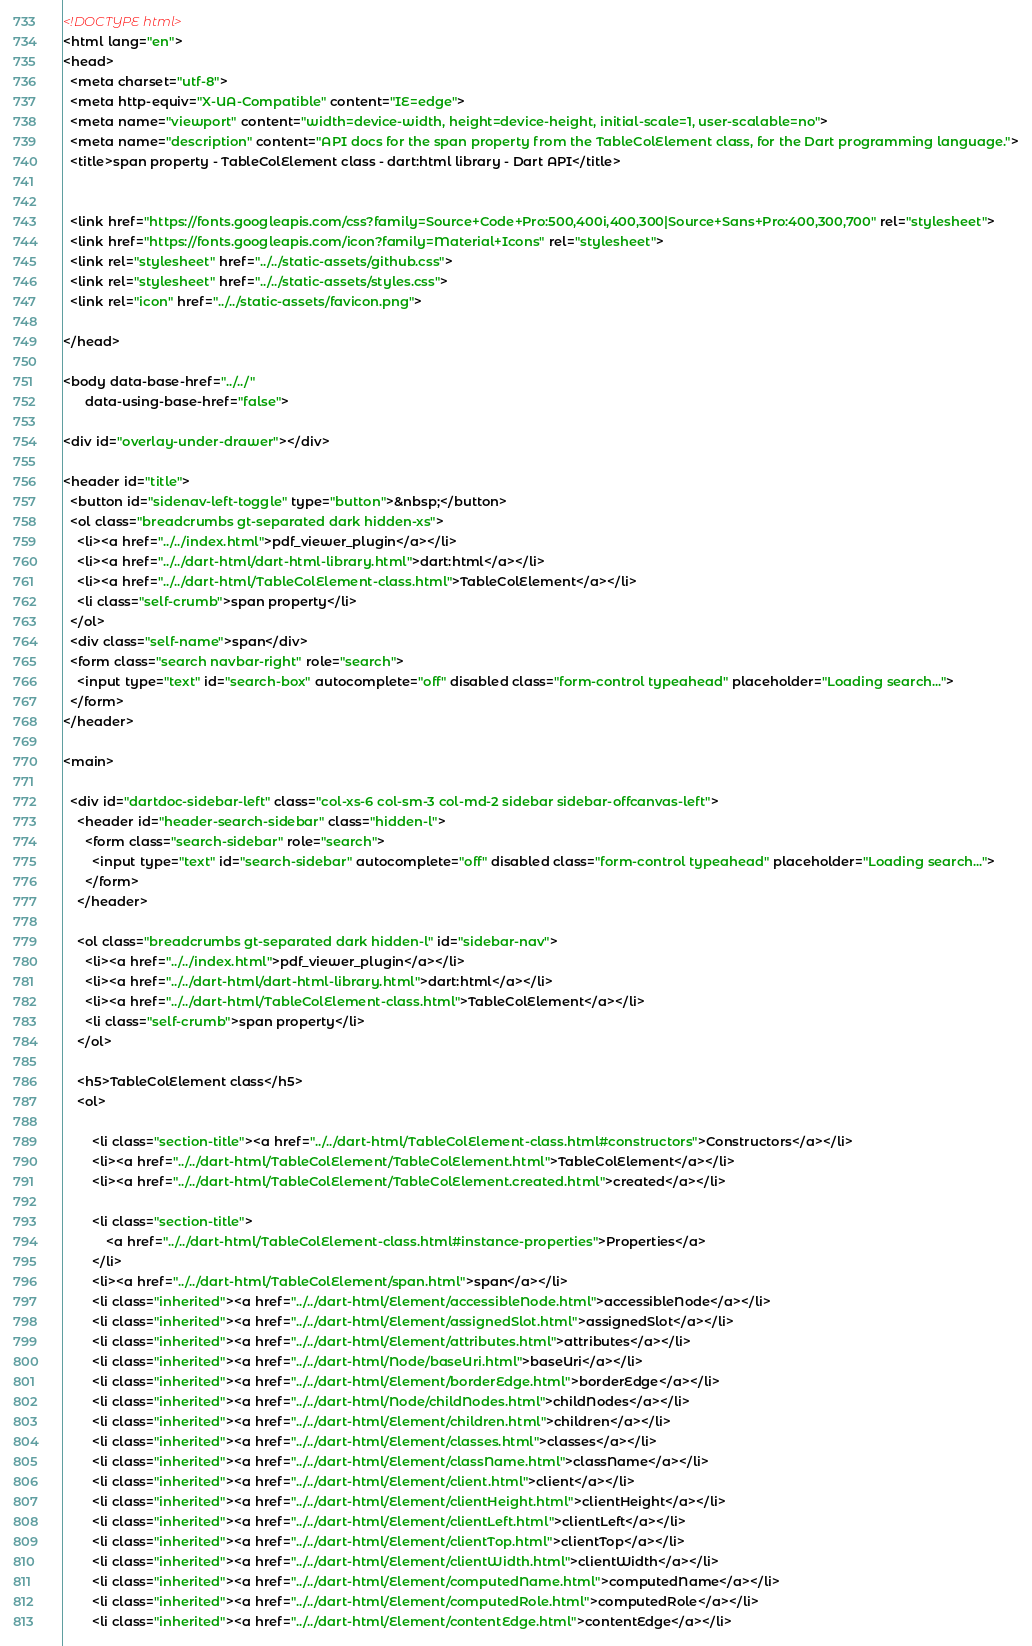Convert code to text. <code><loc_0><loc_0><loc_500><loc_500><_HTML_><!DOCTYPE html>
<html lang="en">
<head>
  <meta charset="utf-8">
  <meta http-equiv="X-UA-Compatible" content="IE=edge">
  <meta name="viewport" content="width=device-width, height=device-height, initial-scale=1, user-scalable=no">
  <meta name="description" content="API docs for the span property from the TableColElement class, for the Dart programming language.">
  <title>span property - TableColElement class - dart:html library - Dart API</title>

  
  <link href="https://fonts.googleapis.com/css?family=Source+Code+Pro:500,400i,400,300|Source+Sans+Pro:400,300,700" rel="stylesheet">
  <link href="https://fonts.googleapis.com/icon?family=Material+Icons" rel="stylesheet">
  <link rel="stylesheet" href="../../static-assets/github.css">
  <link rel="stylesheet" href="../../static-assets/styles.css">
  <link rel="icon" href="../../static-assets/favicon.png">

</head>

<body data-base-href="../../"
      data-using-base-href="false">

<div id="overlay-under-drawer"></div>

<header id="title">
  <button id="sidenav-left-toggle" type="button">&nbsp;</button>
  <ol class="breadcrumbs gt-separated dark hidden-xs">
    <li><a href="../../index.html">pdf_viewer_plugin</a></li>
    <li><a href="../../dart-html/dart-html-library.html">dart:html</a></li>
    <li><a href="../../dart-html/TableColElement-class.html">TableColElement</a></li>
    <li class="self-crumb">span property</li>
  </ol>
  <div class="self-name">span</div>
  <form class="search navbar-right" role="search">
    <input type="text" id="search-box" autocomplete="off" disabled class="form-control typeahead" placeholder="Loading search...">
  </form>
</header>

<main>

  <div id="dartdoc-sidebar-left" class="col-xs-6 col-sm-3 col-md-2 sidebar sidebar-offcanvas-left">
    <header id="header-search-sidebar" class="hidden-l">
      <form class="search-sidebar" role="search">
        <input type="text" id="search-sidebar" autocomplete="off" disabled class="form-control typeahead" placeholder="Loading search...">
      </form>
    </header>
    
    <ol class="breadcrumbs gt-separated dark hidden-l" id="sidebar-nav">
      <li><a href="../../index.html">pdf_viewer_plugin</a></li>
      <li><a href="../../dart-html/dart-html-library.html">dart:html</a></li>
      <li><a href="../../dart-html/TableColElement-class.html">TableColElement</a></li>
      <li class="self-crumb">span property</li>
    </ol>
    
    <h5>TableColElement class</h5>
    <ol>
    
        <li class="section-title"><a href="../../dart-html/TableColElement-class.html#constructors">Constructors</a></li>
        <li><a href="../../dart-html/TableColElement/TableColElement.html">TableColElement</a></li>
        <li><a href="../../dart-html/TableColElement/TableColElement.created.html">created</a></li>
    
        <li class="section-title">
            <a href="../../dart-html/TableColElement-class.html#instance-properties">Properties</a>
        </li>
        <li><a href="../../dart-html/TableColElement/span.html">span</a></li>
        <li class="inherited"><a href="../../dart-html/Element/accessibleNode.html">accessibleNode</a></li>
        <li class="inherited"><a href="../../dart-html/Element/assignedSlot.html">assignedSlot</a></li>
        <li class="inherited"><a href="../../dart-html/Element/attributes.html">attributes</a></li>
        <li class="inherited"><a href="../../dart-html/Node/baseUri.html">baseUri</a></li>
        <li class="inherited"><a href="../../dart-html/Element/borderEdge.html">borderEdge</a></li>
        <li class="inherited"><a href="../../dart-html/Node/childNodes.html">childNodes</a></li>
        <li class="inherited"><a href="../../dart-html/Element/children.html">children</a></li>
        <li class="inherited"><a href="../../dart-html/Element/classes.html">classes</a></li>
        <li class="inherited"><a href="../../dart-html/Element/className.html">className</a></li>
        <li class="inherited"><a href="../../dart-html/Element/client.html">client</a></li>
        <li class="inherited"><a href="../../dart-html/Element/clientHeight.html">clientHeight</a></li>
        <li class="inherited"><a href="../../dart-html/Element/clientLeft.html">clientLeft</a></li>
        <li class="inherited"><a href="../../dart-html/Element/clientTop.html">clientTop</a></li>
        <li class="inherited"><a href="../../dart-html/Element/clientWidth.html">clientWidth</a></li>
        <li class="inherited"><a href="../../dart-html/Element/computedName.html">computedName</a></li>
        <li class="inherited"><a href="../../dart-html/Element/computedRole.html">computedRole</a></li>
        <li class="inherited"><a href="../../dart-html/Element/contentEdge.html">contentEdge</a></li></code> 